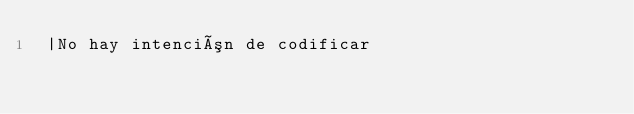Convert code to text. <code><loc_0><loc_0><loc_500><loc_500><_SQL_> |No hay intención de codificar
</code> 